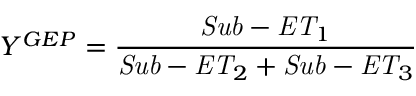<formula> <loc_0><loc_0><loc_500><loc_500>Y ^ { G E P } = \frac { S u b - E T _ { 1 } } { S u b - E T _ { 2 } + S u b - E T _ { 3 } }</formula> 